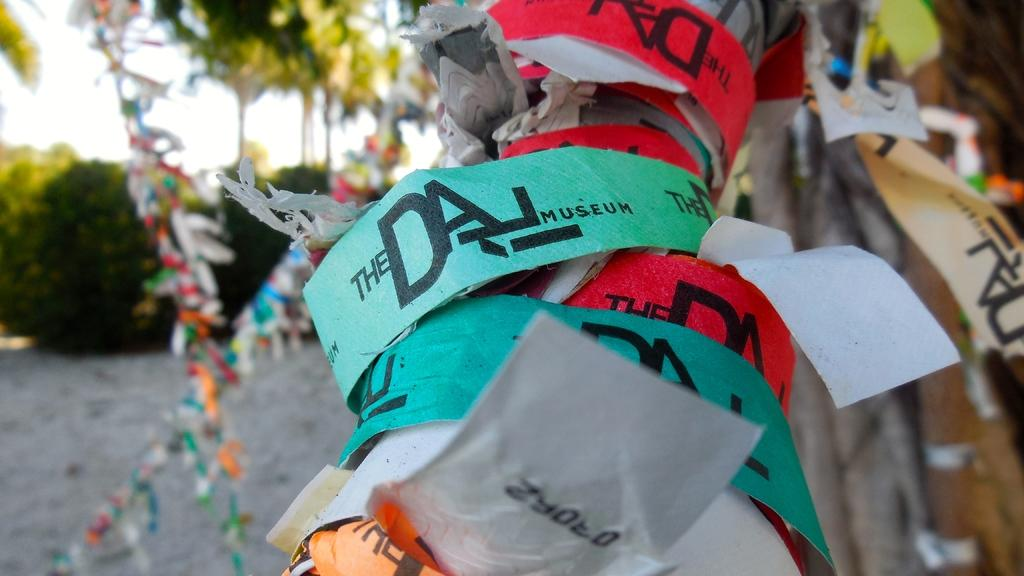What is located in the center of the image? There are labels in the center of the image. What type of material is featured in the image? There are colorful papers in the image. What can be seen in the background of the image? There are cars in the background of the image. What rule is being enforced in the field in the image? There is no field or rule present in the image; it features labels and colorful papers with cars in the background. 